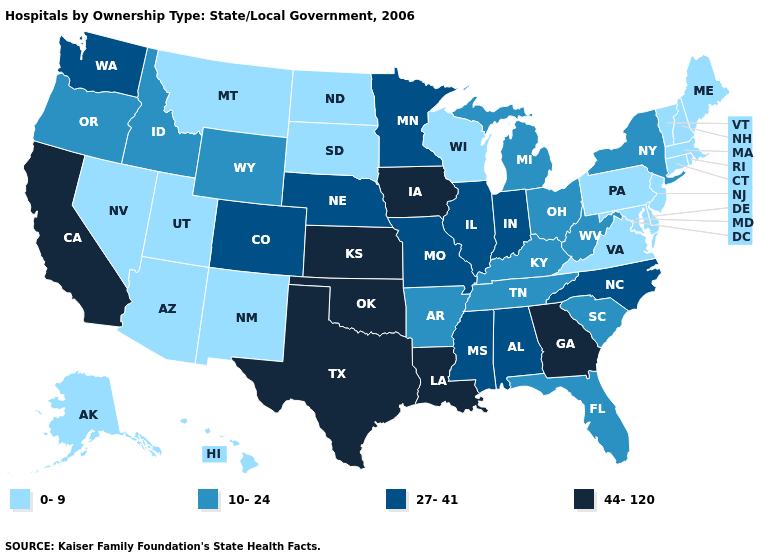Does Michigan have the lowest value in the USA?
Short answer required. No. Name the states that have a value in the range 0-9?
Be succinct. Alaska, Arizona, Connecticut, Delaware, Hawaii, Maine, Maryland, Massachusetts, Montana, Nevada, New Hampshire, New Jersey, New Mexico, North Dakota, Pennsylvania, Rhode Island, South Dakota, Utah, Vermont, Virginia, Wisconsin. Name the states that have a value in the range 0-9?
Write a very short answer. Alaska, Arizona, Connecticut, Delaware, Hawaii, Maine, Maryland, Massachusetts, Montana, Nevada, New Hampshire, New Jersey, New Mexico, North Dakota, Pennsylvania, Rhode Island, South Dakota, Utah, Vermont, Virginia, Wisconsin. What is the value of Rhode Island?
Be succinct. 0-9. Does the first symbol in the legend represent the smallest category?
Answer briefly. Yes. Does Iowa have the highest value in the USA?
Answer briefly. Yes. What is the value of South Carolina?
Answer briefly. 10-24. Is the legend a continuous bar?
Write a very short answer. No. Does Michigan have the highest value in the USA?
Short answer required. No. Does the map have missing data?
Concise answer only. No. What is the lowest value in the USA?
Give a very brief answer. 0-9. Does Michigan have the lowest value in the USA?
Keep it brief. No. What is the value of Connecticut?
Give a very brief answer. 0-9. What is the highest value in the MidWest ?
Quick response, please. 44-120. Does Tennessee have the same value as Nebraska?
Concise answer only. No. 